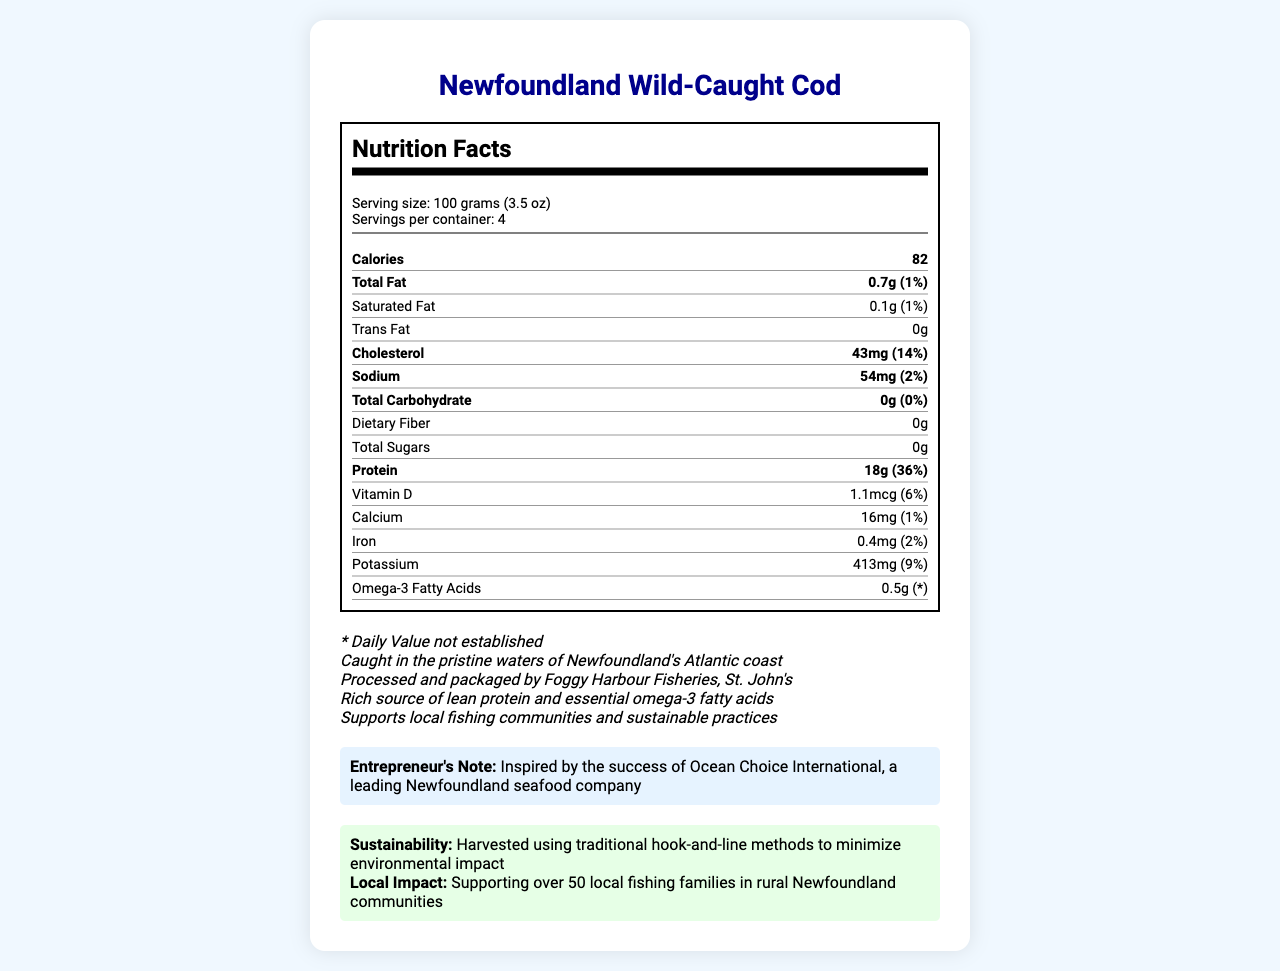what is the serving size of Newfoundland Wild-Caught Cod? The serving size is mentioned at the beginning of the nutrition facts section.
Answer: 100 grams (3.5 oz) how many calories are there per serving? The calories per serving are listed as 82 in the nutrition label.
Answer: 82 how much protein is in one serving of cod? The amount of protein per serving is stated as 18g in the nutrition label.
Answer: 18g what are the total carbohydrates in one serving? The total carbohydrate content is given as 0g in the nutrition label.
Answer: 0g how much cholesterol does one serving contain? The amount of cholesterol in one serving is listed as 43mg in the nutrition label.
Answer: 43mg what percentage of the daily value is sodium? The daily value percentage for sodium is indicated as 2% in the nutrition label.
Answer: 2% where is the cod caught? The cod is caught in the pristine waters of Newfoundland's Atlantic coast, as mentioned in the additional info.
Answer: Pristine waters of Newfoundland's Atlantic coast how many servings are there per container? There are 4 servings per container, as stated in the nutrition facts.
Answer: 4 which local business processes and packages the cod? The cod is processed and packaged by Foggy Harbour Fisheries, St. John's, according to the additional info.
Answer: Foggy Harbour Fisheries, St. John's which fatty acid is highlighted in the nutrition label? A. Omega-6 B. Omega-3 C. Omega-7 The nutrition label highlights that the cod contains omega-3 fatty acids.
Answer: B. Omega-3 what is the total fat content per serving? A. 0.3g B. 0.5g C. 0.7g D. 1.0g The nutrition label lists the total fat content per serving as 0.7g.
Answer: C. 0.7g what is the amount of potassium in one serving? The amount of potassium per serving is given as 413mg in the nutrition label.
Answer: 413mg does the cod contain any trans fat? The nutrition label states that the product contains 0g of trans fat.
Answer: No describe the main idea of the document. The document encompasses the nutritional details of the product, its local sourcing and processing, support for local fishing communities, and adherence to sustainable practices.
Answer: The document provides the nutrition facts for Newfoundland Wild-Caught Cod, emphasizing its high protein and omega-3 fatty acid content. It highlights the product's sourcing from Newfoundland waters, its processing by a local business, and its contribution to sustainable fishing practices. how much vitamin D is in one serving? The amount of vitamin D per serving is listed as 1.1mcg in the nutrition label.
Answer: 1.1mcg what does the sustainability statement mention about fishing methods? The sustainability statement mentions that the cod is harvested using traditional hook-and-line methods to minimize environmental impact.
Answer: Harvested using traditional hook-and-line methods how many fishing families are supported by this business? The local business impact section states that over 50 local fishing families are supported by this business.
Answer: Over 50 families who is the entrepreneur inspired by? The entrepreneur's note mentions inspiration by the success of Ocean Choice International, a leading Newfoundland seafood company.
Answer: Ocean Choice International what is the total sugar content per serving? The nutrition label indicates that there are 0g of total sugars per serving.
Answer: 0g how much omega-3 fish oil should adults consume daily? The document does not provide information about the recommended daily intake of omega-3 fish oil for adults.
Answer: Cannot be determined 